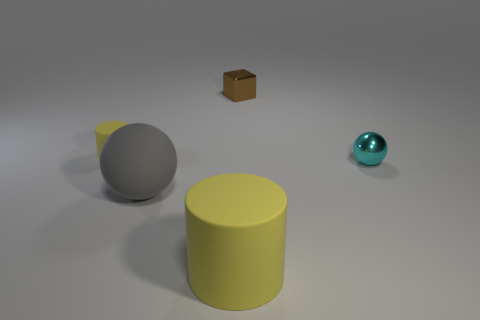What shape is the tiny rubber thing that is the same color as the big cylinder?
Your answer should be compact. Cylinder. Does the big matte cylinder have the same color as the tiny rubber thing?
Keep it short and to the point. Yes. How many big things have the same material as the small brown thing?
Ensure brevity in your answer.  0. What is the color of the object that is the same material as the cyan ball?
Make the answer very short. Brown. There is a cylinder right of the tiny yellow cylinder; does it have the same color as the small rubber thing?
Provide a succinct answer. Yes. There is a tiny object left of the small brown shiny thing; what is it made of?
Offer a very short reply. Rubber. Is the number of large balls that are on the left side of the big yellow cylinder the same as the number of tiny yellow cylinders?
Keep it short and to the point. Yes. What number of other spheres have the same color as the large rubber sphere?
Give a very brief answer. 0. There is a big matte object that is the same shape as the small yellow object; what color is it?
Give a very brief answer. Yellow. Do the cube and the gray rubber ball have the same size?
Your answer should be very brief. No. 